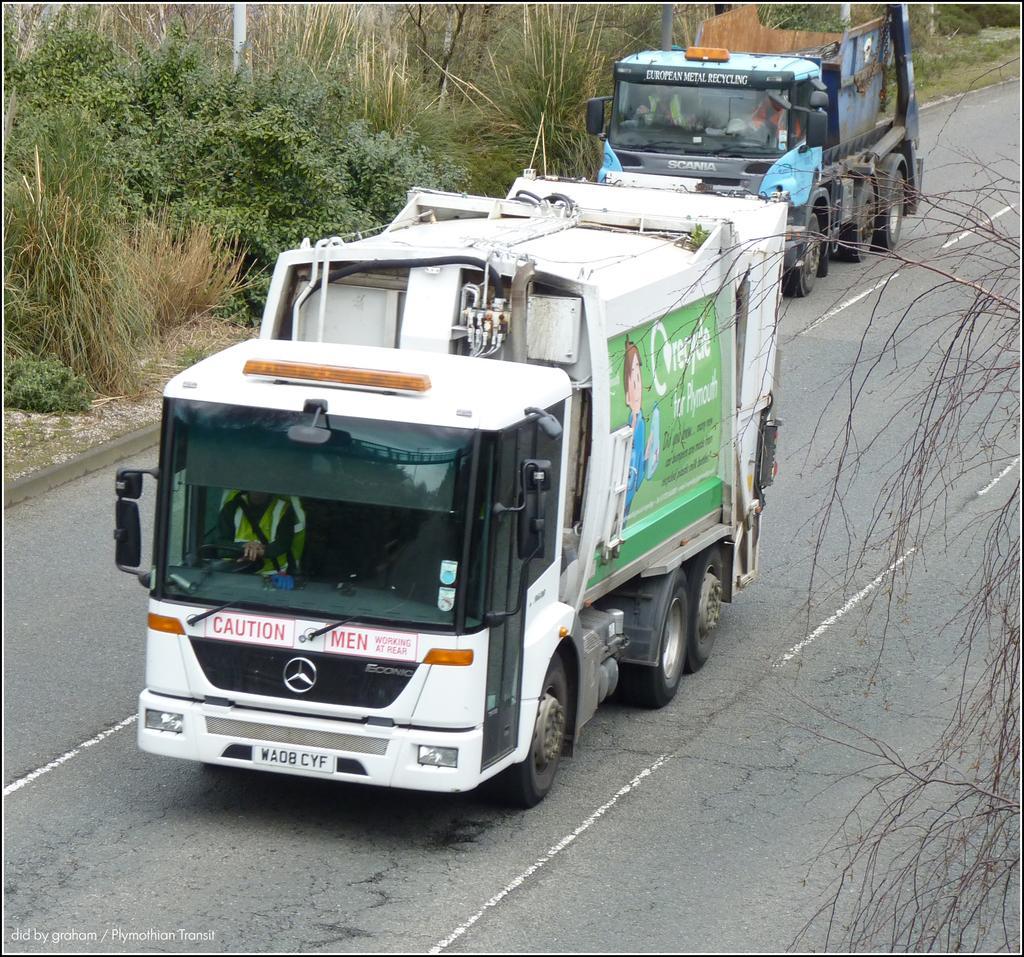Could you give a brief overview of what you see in this image? In this image we can see the vehicles passing on the road. Image also consists of trees and also grass and the image has borders. In the bottom left corner we can see the text. 